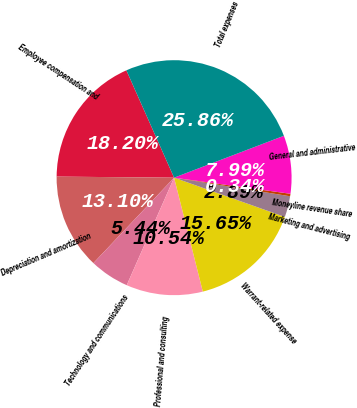Convert chart. <chart><loc_0><loc_0><loc_500><loc_500><pie_chart><fcel>Employee compensation and<fcel>Depreciation and amortization<fcel>Technology and communications<fcel>Professional and consulting<fcel>Warrant-related expense<fcel>Marketing and advertising<fcel>Moneyline revenue share<fcel>General and administrative<fcel>Total expenses<nl><fcel>18.2%<fcel>13.1%<fcel>5.44%<fcel>10.54%<fcel>15.65%<fcel>2.89%<fcel>0.34%<fcel>7.99%<fcel>25.86%<nl></chart> 